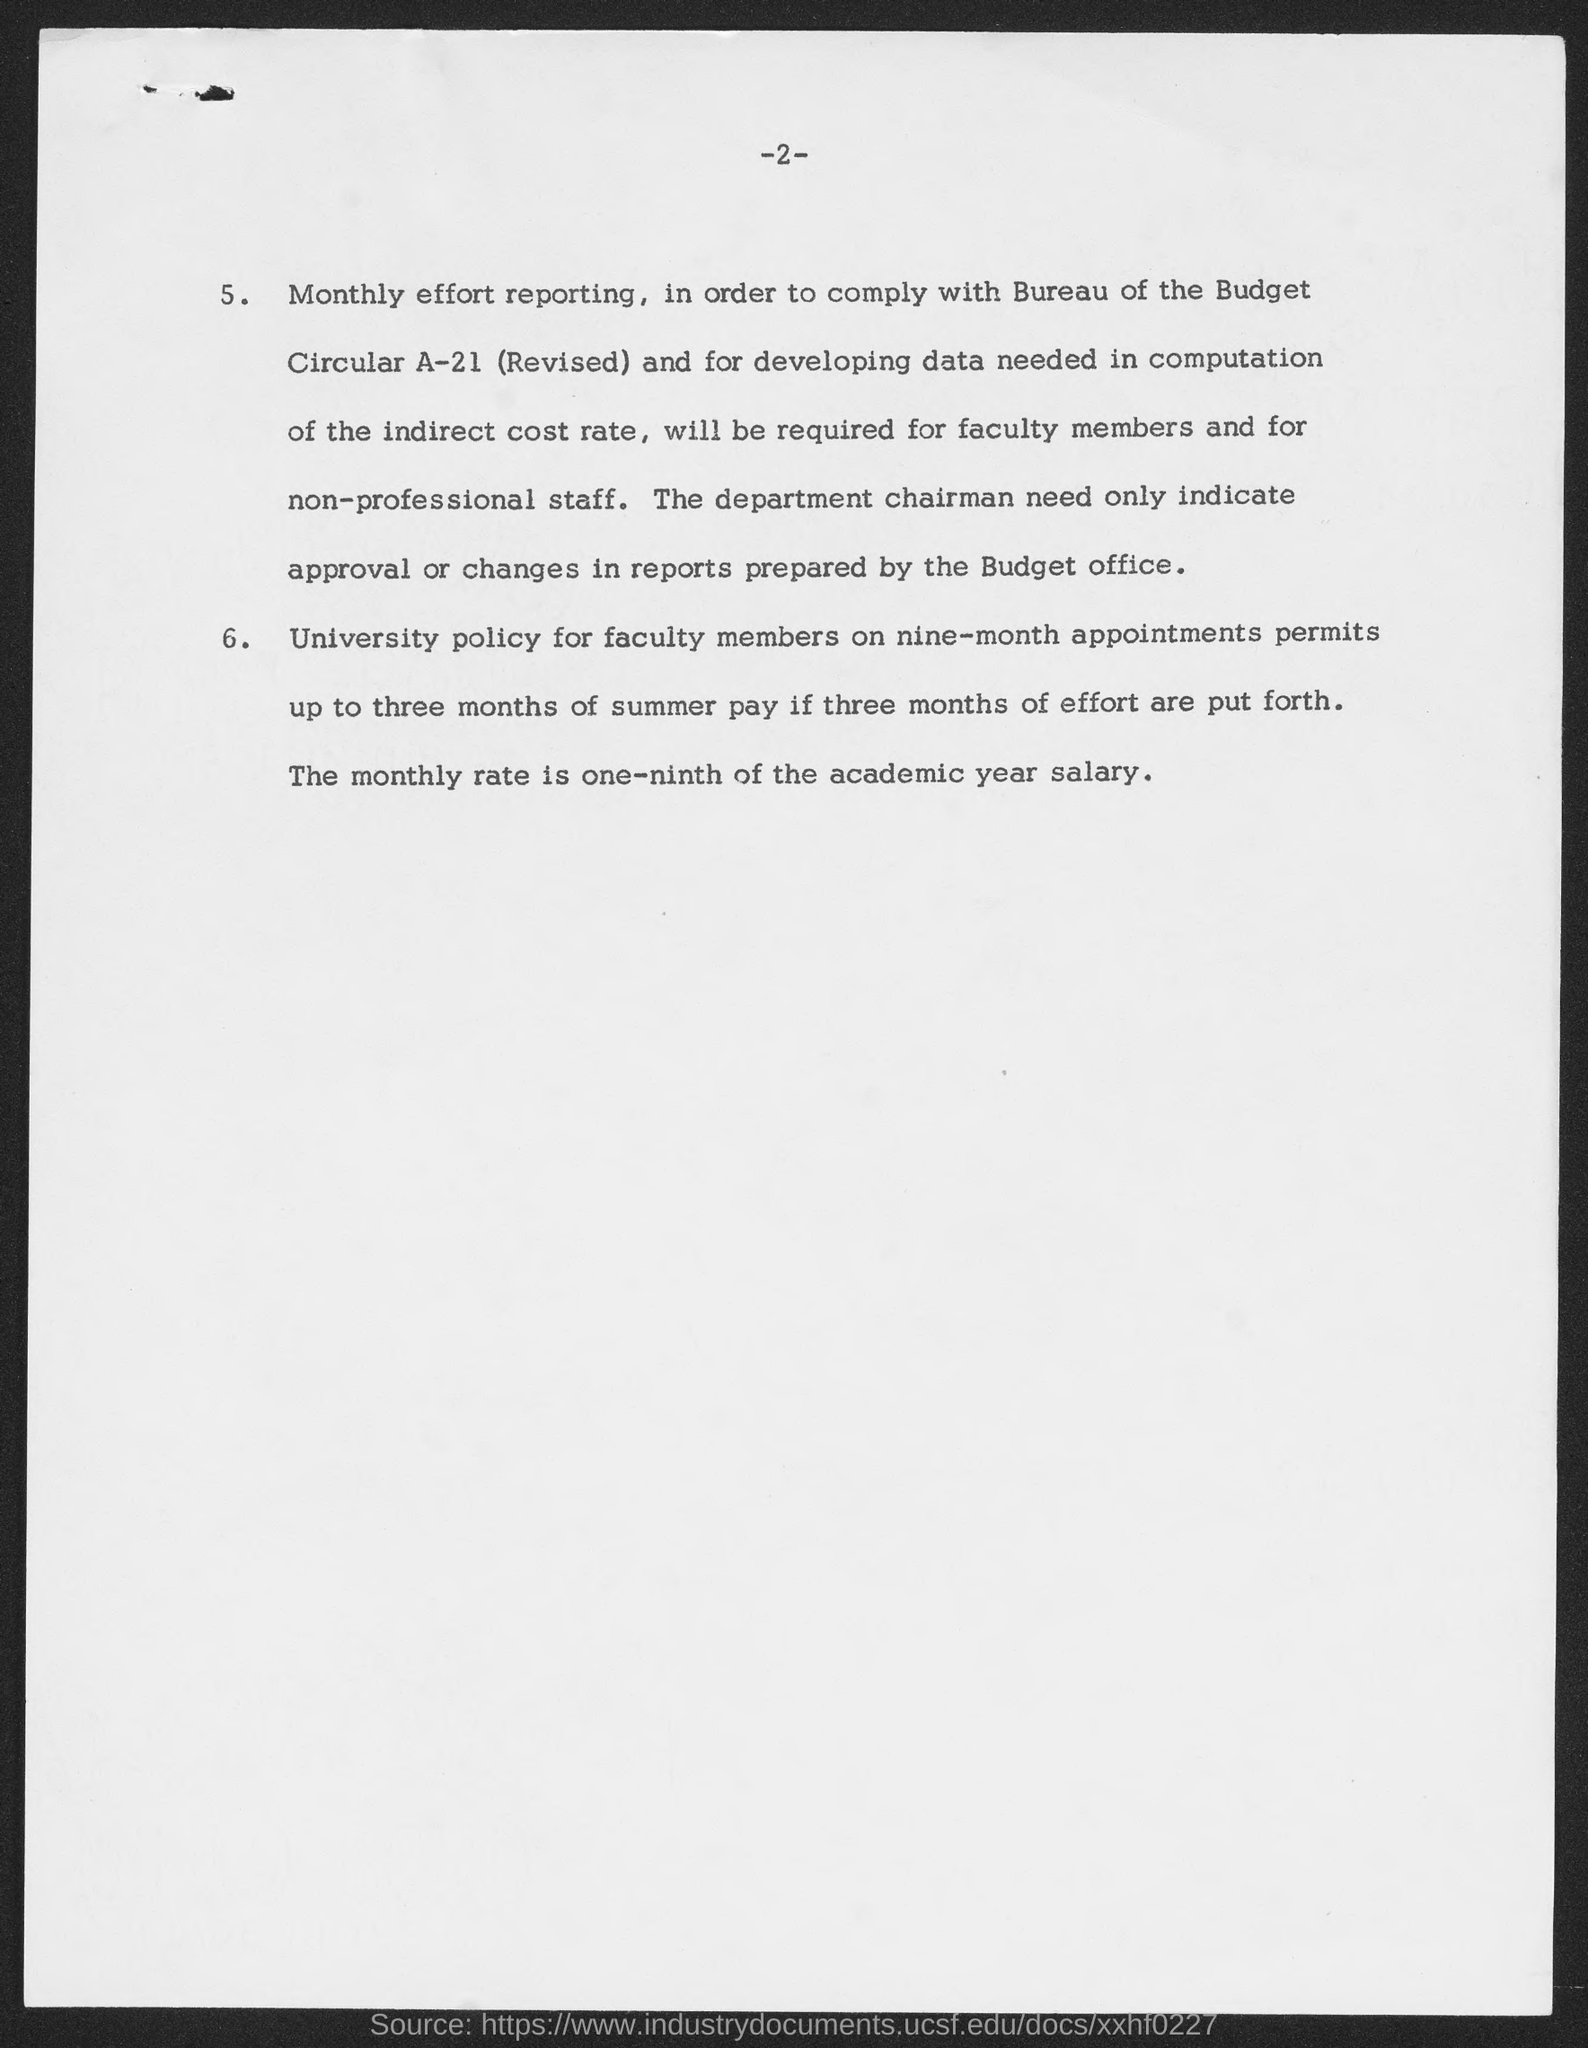Draw attention to some important aspects in this diagram. The page number at the top of the page is 2. 